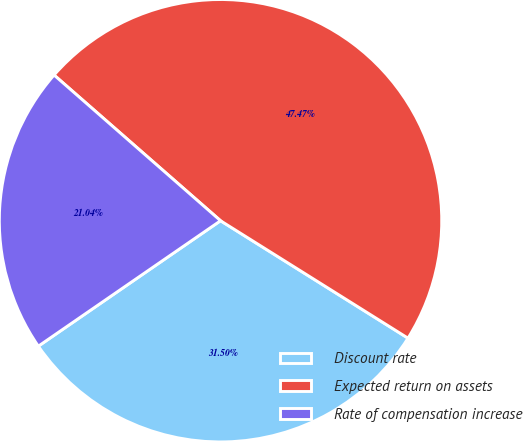Convert chart to OTSL. <chart><loc_0><loc_0><loc_500><loc_500><pie_chart><fcel>Discount rate<fcel>Expected return on assets<fcel>Rate of compensation increase<nl><fcel>31.5%<fcel>47.47%<fcel>21.04%<nl></chart> 